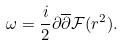<formula> <loc_0><loc_0><loc_500><loc_500>\omega = \frac { i } { 2 } \partial \overline { \partial } \mathcal { F } ( r ^ { 2 } ) .</formula> 